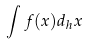<formula> <loc_0><loc_0><loc_500><loc_500>\int f ( x ) d _ { h } x</formula> 